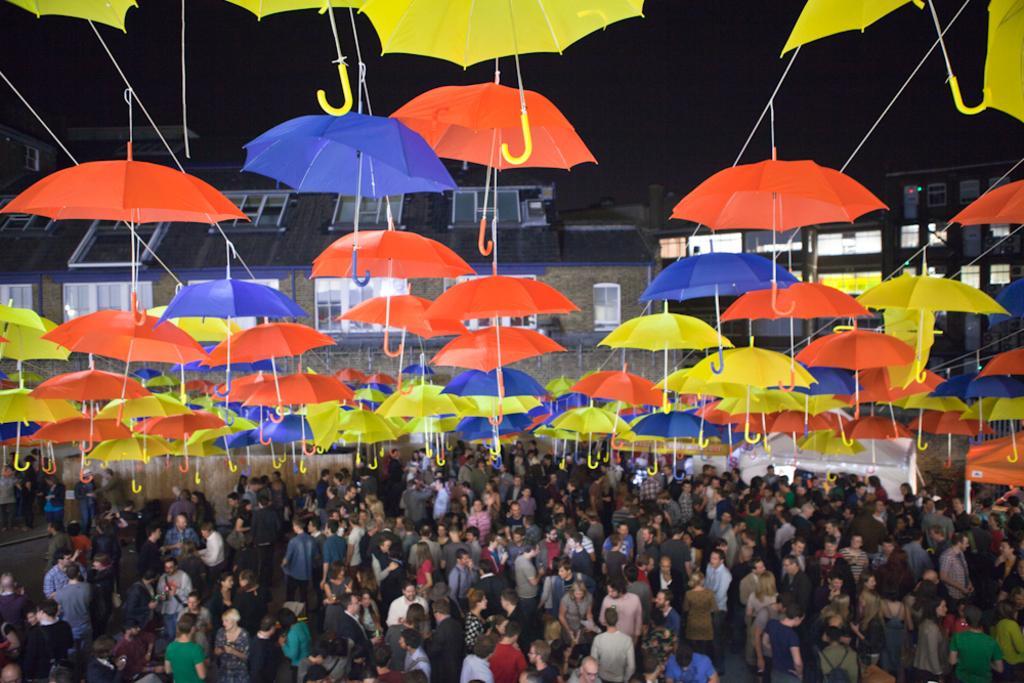Describe this image in one or two sentences. In this image, there are some people standing, there are some umbrellas which are in yellow, orange and blue color at the top, at the background there are some homes. 